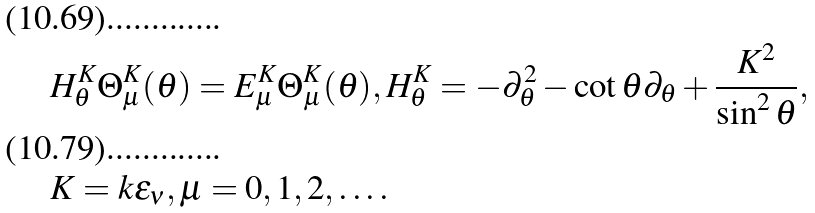Convert formula to latex. <formula><loc_0><loc_0><loc_500><loc_500>& H ^ { K } _ { \theta } \Theta ^ { K } _ { \mu } ( \theta ) = E ^ { K } _ { \mu } \Theta ^ { K } _ { \mu } ( \theta ) , H ^ { K } _ { \theta } = - \partial _ { \theta } ^ { 2 } - \cot \theta \partial _ { \theta } + \frac { K ^ { 2 } } { \sin ^ { 2 } \theta } , \\ & K = k \epsilon _ { \nu } , \mu = 0 , 1 , 2 , \dots .</formula> 